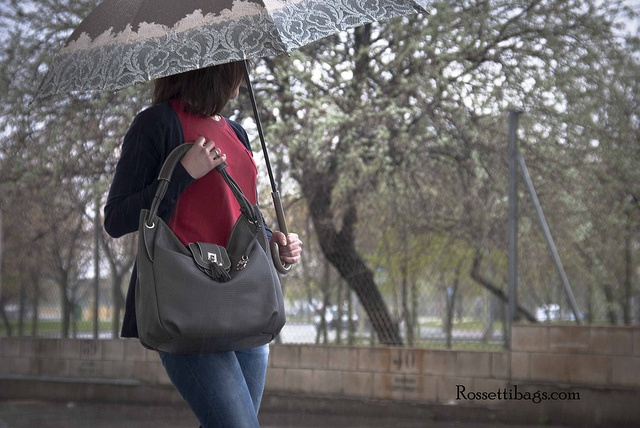Describe the objects in this image and their specific colors. I can see people in gray, black, maroon, and brown tones, umbrella in gray, darkgray, and lightgray tones, and handbag in gray, black, and darkgray tones in this image. 